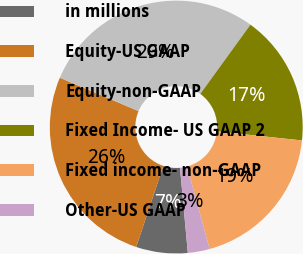<chart> <loc_0><loc_0><loc_500><loc_500><pie_chart><fcel>in millions<fcel>Equity-US GAAP<fcel>Equity-non-GAAP<fcel>Fixed Income- US GAAP 2<fcel>Fixed income- non-GAAP<fcel>Other-US GAAP<nl><fcel>6.59%<fcel>26.25%<fcel>28.6%<fcel>16.71%<fcel>19.06%<fcel>2.79%<nl></chart> 